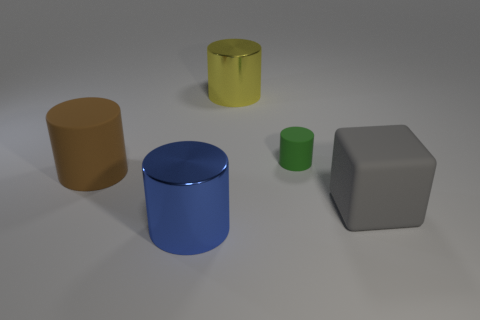Which objects in the image have a reflective surface? The metallic cylinders appear to have reflective surfaces, as indicated by the light and shadow patterns on them. 